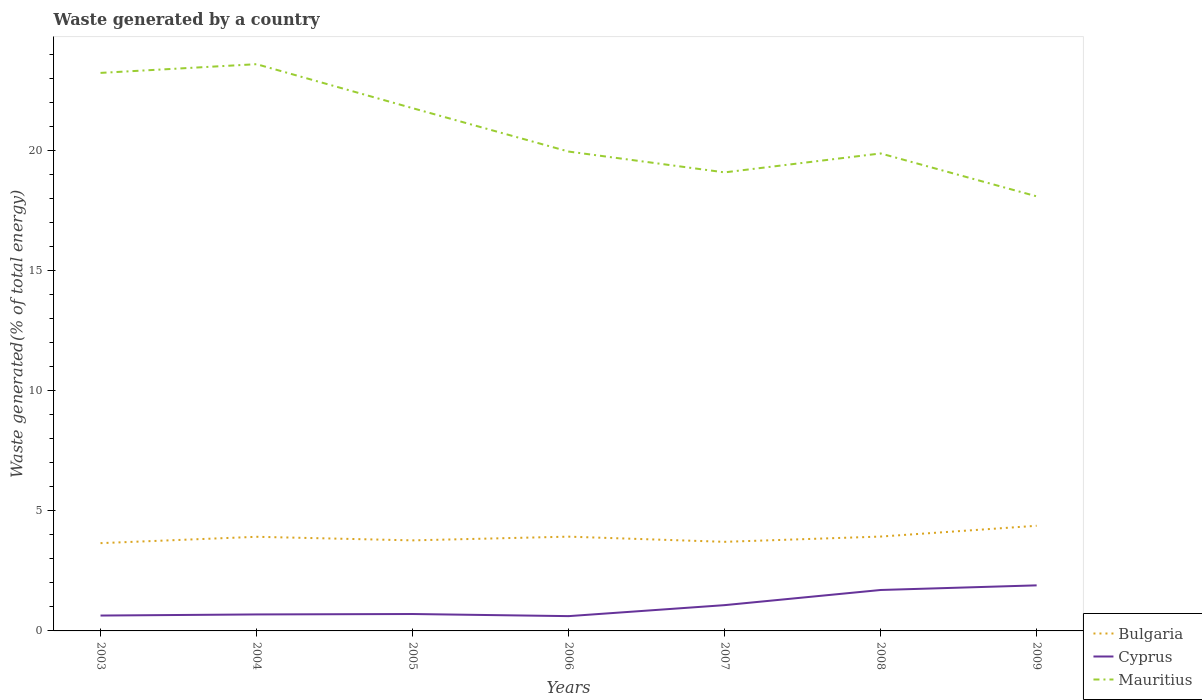Does the line corresponding to Mauritius intersect with the line corresponding to Cyprus?
Your response must be concise. No. Across all years, what is the maximum total waste generated in Cyprus?
Give a very brief answer. 0.62. What is the total total waste generated in Cyprus in the graph?
Provide a succinct answer. -0.63. What is the difference between the highest and the second highest total waste generated in Cyprus?
Offer a very short reply. 1.28. What is the difference between the highest and the lowest total waste generated in Cyprus?
Offer a very short reply. 3. How many years are there in the graph?
Provide a short and direct response. 7. Does the graph contain any zero values?
Your answer should be very brief. No. Does the graph contain grids?
Your answer should be very brief. No. Where does the legend appear in the graph?
Provide a succinct answer. Bottom right. How many legend labels are there?
Your response must be concise. 3. What is the title of the graph?
Your answer should be very brief. Waste generated by a country. Does "Cote d'Ivoire" appear as one of the legend labels in the graph?
Make the answer very short. No. What is the label or title of the X-axis?
Your response must be concise. Years. What is the label or title of the Y-axis?
Provide a succinct answer. Waste generated(% of total energy). What is the Waste generated(% of total energy) of Bulgaria in 2003?
Your answer should be compact. 3.66. What is the Waste generated(% of total energy) in Cyprus in 2003?
Your response must be concise. 0.64. What is the Waste generated(% of total energy) of Mauritius in 2003?
Offer a very short reply. 23.24. What is the Waste generated(% of total energy) of Bulgaria in 2004?
Give a very brief answer. 3.92. What is the Waste generated(% of total energy) in Cyprus in 2004?
Give a very brief answer. 0.69. What is the Waste generated(% of total energy) in Mauritius in 2004?
Give a very brief answer. 23.6. What is the Waste generated(% of total energy) of Bulgaria in 2005?
Offer a terse response. 3.77. What is the Waste generated(% of total energy) of Cyprus in 2005?
Give a very brief answer. 0.7. What is the Waste generated(% of total energy) in Mauritius in 2005?
Your answer should be very brief. 21.77. What is the Waste generated(% of total energy) in Bulgaria in 2006?
Your answer should be compact. 3.93. What is the Waste generated(% of total energy) in Cyprus in 2006?
Make the answer very short. 0.62. What is the Waste generated(% of total energy) of Mauritius in 2006?
Provide a succinct answer. 19.96. What is the Waste generated(% of total energy) of Bulgaria in 2007?
Keep it short and to the point. 3.71. What is the Waste generated(% of total energy) in Cyprus in 2007?
Give a very brief answer. 1.07. What is the Waste generated(% of total energy) of Mauritius in 2007?
Keep it short and to the point. 19.1. What is the Waste generated(% of total energy) of Bulgaria in 2008?
Your answer should be compact. 3.93. What is the Waste generated(% of total energy) in Cyprus in 2008?
Offer a very short reply. 1.7. What is the Waste generated(% of total energy) in Mauritius in 2008?
Offer a terse response. 19.88. What is the Waste generated(% of total energy) of Bulgaria in 2009?
Keep it short and to the point. 4.38. What is the Waste generated(% of total energy) in Cyprus in 2009?
Your response must be concise. 1.9. What is the Waste generated(% of total energy) of Mauritius in 2009?
Make the answer very short. 18.1. Across all years, what is the maximum Waste generated(% of total energy) in Bulgaria?
Your answer should be compact. 4.38. Across all years, what is the maximum Waste generated(% of total energy) of Cyprus?
Offer a terse response. 1.9. Across all years, what is the maximum Waste generated(% of total energy) of Mauritius?
Provide a short and direct response. 23.6. Across all years, what is the minimum Waste generated(% of total energy) in Bulgaria?
Your answer should be very brief. 3.66. Across all years, what is the minimum Waste generated(% of total energy) in Cyprus?
Ensure brevity in your answer.  0.62. Across all years, what is the minimum Waste generated(% of total energy) in Mauritius?
Your response must be concise. 18.1. What is the total Waste generated(% of total energy) in Bulgaria in the graph?
Keep it short and to the point. 27.29. What is the total Waste generated(% of total energy) in Cyprus in the graph?
Offer a terse response. 7.32. What is the total Waste generated(% of total energy) of Mauritius in the graph?
Offer a very short reply. 145.65. What is the difference between the Waste generated(% of total energy) in Bulgaria in 2003 and that in 2004?
Your response must be concise. -0.26. What is the difference between the Waste generated(% of total energy) of Cyprus in 2003 and that in 2004?
Your answer should be very brief. -0.05. What is the difference between the Waste generated(% of total energy) of Mauritius in 2003 and that in 2004?
Give a very brief answer. -0.36. What is the difference between the Waste generated(% of total energy) of Bulgaria in 2003 and that in 2005?
Give a very brief answer. -0.12. What is the difference between the Waste generated(% of total energy) of Cyprus in 2003 and that in 2005?
Offer a very short reply. -0.06. What is the difference between the Waste generated(% of total energy) in Mauritius in 2003 and that in 2005?
Ensure brevity in your answer.  1.47. What is the difference between the Waste generated(% of total energy) of Bulgaria in 2003 and that in 2006?
Make the answer very short. -0.27. What is the difference between the Waste generated(% of total energy) in Cyprus in 2003 and that in 2006?
Give a very brief answer. 0.02. What is the difference between the Waste generated(% of total energy) of Mauritius in 2003 and that in 2006?
Offer a terse response. 3.28. What is the difference between the Waste generated(% of total energy) of Bulgaria in 2003 and that in 2007?
Your answer should be compact. -0.06. What is the difference between the Waste generated(% of total energy) of Cyprus in 2003 and that in 2007?
Offer a very short reply. -0.43. What is the difference between the Waste generated(% of total energy) of Mauritius in 2003 and that in 2007?
Give a very brief answer. 4.14. What is the difference between the Waste generated(% of total energy) in Bulgaria in 2003 and that in 2008?
Keep it short and to the point. -0.27. What is the difference between the Waste generated(% of total energy) in Cyprus in 2003 and that in 2008?
Give a very brief answer. -1.06. What is the difference between the Waste generated(% of total energy) in Mauritius in 2003 and that in 2008?
Make the answer very short. 3.35. What is the difference between the Waste generated(% of total energy) in Bulgaria in 2003 and that in 2009?
Keep it short and to the point. -0.72. What is the difference between the Waste generated(% of total energy) in Cyprus in 2003 and that in 2009?
Your answer should be very brief. -1.26. What is the difference between the Waste generated(% of total energy) of Mauritius in 2003 and that in 2009?
Make the answer very short. 5.14. What is the difference between the Waste generated(% of total energy) of Bulgaria in 2004 and that in 2005?
Provide a succinct answer. 0.15. What is the difference between the Waste generated(% of total energy) of Cyprus in 2004 and that in 2005?
Your answer should be compact. -0.02. What is the difference between the Waste generated(% of total energy) in Mauritius in 2004 and that in 2005?
Your answer should be very brief. 1.83. What is the difference between the Waste generated(% of total energy) of Bulgaria in 2004 and that in 2006?
Offer a very short reply. -0.01. What is the difference between the Waste generated(% of total energy) in Cyprus in 2004 and that in 2006?
Provide a succinct answer. 0.07. What is the difference between the Waste generated(% of total energy) of Mauritius in 2004 and that in 2006?
Ensure brevity in your answer.  3.64. What is the difference between the Waste generated(% of total energy) in Bulgaria in 2004 and that in 2007?
Your response must be concise. 0.21. What is the difference between the Waste generated(% of total energy) in Cyprus in 2004 and that in 2007?
Your response must be concise. -0.39. What is the difference between the Waste generated(% of total energy) of Mauritius in 2004 and that in 2007?
Provide a short and direct response. 4.51. What is the difference between the Waste generated(% of total energy) of Bulgaria in 2004 and that in 2008?
Offer a very short reply. -0.01. What is the difference between the Waste generated(% of total energy) of Cyprus in 2004 and that in 2008?
Offer a terse response. -1.02. What is the difference between the Waste generated(% of total energy) in Mauritius in 2004 and that in 2008?
Your answer should be compact. 3.72. What is the difference between the Waste generated(% of total energy) of Bulgaria in 2004 and that in 2009?
Ensure brevity in your answer.  -0.46. What is the difference between the Waste generated(% of total energy) in Cyprus in 2004 and that in 2009?
Ensure brevity in your answer.  -1.21. What is the difference between the Waste generated(% of total energy) in Mauritius in 2004 and that in 2009?
Make the answer very short. 5.5. What is the difference between the Waste generated(% of total energy) of Bulgaria in 2005 and that in 2006?
Provide a succinct answer. -0.15. What is the difference between the Waste generated(% of total energy) in Cyprus in 2005 and that in 2006?
Offer a very short reply. 0.09. What is the difference between the Waste generated(% of total energy) in Mauritius in 2005 and that in 2006?
Your response must be concise. 1.81. What is the difference between the Waste generated(% of total energy) of Bulgaria in 2005 and that in 2007?
Give a very brief answer. 0.06. What is the difference between the Waste generated(% of total energy) in Cyprus in 2005 and that in 2007?
Your response must be concise. -0.37. What is the difference between the Waste generated(% of total energy) in Mauritius in 2005 and that in 2007?
Your answer should be very brief. 2.67. What is the difference between the Waste generated(% of total energy) in Bulgaria in 2005 and that in 2008?
Give a very brief answer. -0.16. What is the difference between the Waste generated(% of total energy) in Cyprus in 2005 and that in 2008?
Ensure brevity in your answer.  -1. What is the difference between the Waste generated(% of total energy) of Mauritius in 2005 and that in 2008?
Keep it short and to the point. 1.89. What is the difference between the Waste generated(% of total energy) of Bulgaria in 2005 and that in 2009?
Ensure brevity in your answer.  -0.61. What is the difference between the Waste generated(% of total energy) in Cyprus in 2005 and that in 2009?
Give a very brief answer. -1.19. What is the difference between the Waste generated(% of total energy) in Mauritius in 2005 and that in 2009?
Ensure brevity in your answer.  3.67. What is the difference between the Waste generated(% of total energy) of Bulgaria in 2006 and that in 2007?
Your response must be concise. 0.22. What is the difference between the Waste generated(% of total energy) of Cyprus in 2006 and that in 2007?
Keep it short and to the point. -0.46. What is the difference between the Waste generated(% of total energy) of Mauritius in 2006 and that in 2007?
Your answer should be very brief. 0.87. What is the difference between the Waste generated(% of total energy) of Bulgaria in 2006 and that in 2008?
Provide a succinct answer. -0. What is the difference between the Waste generated(% of total energy) of Cyprus in 2006 and that in 2008?
Make the answer very short. -1.09. What is the difference between the Waste generated(% of total energy) of Mauritius in 2006 and that in 2008?
Offer a very short reply. 0.08. What is the difference between the Waste generated(% of total energy) in Bulgaria in 2006 and that in 2009?
Make the answer very short. -0.45. What is the difference between the Waste generated(% of total energy) of Cyprus in 2006 and that in 2009?
Your response must be concise. -1.28. What is the difference between the Waste generated(% of total energy) of Mauritius in 2006 and that in 2009?
Offer a terse response. 1.87. What is the difference between the Waste generated(% of total energy) in Bulgaria in 2007 and that in 2008?
Keep it short and to the point. -0.22. What is the difference between the Waste generated(% of total energy) of Cyprus in 2007 and that in 2008?
Offer a very short reply. -0.63. What is the difference between the Waste generated(% of total energy) in Mauritius in 2007 and that in 2008?
Ensure brevity in your answer.  -0.79. What is the difference between the Waste generated(% of total energy) in Bulgaria in 2007 and that in 2009?
Give a very brief answer. -0.67. What is the difference between the Waste generated(% of total energy) of Cyprus in 2007 and that in 2009?
Give a very brief answer. -0.82. What is the difference between the Waste generated(% of total energy) of Bulgaria in 2008 and that in 2009?
Your answer should be compact. -0.45. What is the difference between the Waste generated(% of total energy) in Cyprus in 2008 and that in 2009?
Offer a terse response. -0.19. What is the difference between the Waste generated(% of total energy) in Mauritius in 2008 and that in 2009?
Your answer should be compact. 1.79. What is the difference between the Waste generated(% of total energy) of Bulgaria in 2003 and the Waste generated(% of total energy) of Cyprus in 2004?
Offer a very short reply. 2.97. What is the difference between the Waste generated(% of total energy) of Bulgaria in 2003 and the Waste generated(% of total energy) of Mauritius in 2004?
Make the answer very short. -19.95. What is the difference between the Waste generated(% of total energy) in Cyprus in 2003 and the Waste generated(% of total energy) in Mauritius in 2004?
Your answer should be very brief. -22.96. What is the difference between the Waste generated(% of total energy) of Bulgaria in 2003 and the Waste generated(% of total energy) of Cyprus in 2005?
Make the answer very short. 2.95. What is the difference between the Waste generated(% of total energy) in Bulgaria in 2003 and the Waste generated(% of total energy) in Mauritius in 2005?
Provide a short and direct response. -18.11. What is the difference between the Waste generated(% of total energy) in Cyprus in 2003 and the Waste generated(% of total energy) in Mauritius in 2005?
Offer a very short reply. -21.13. What is the difference between the Waste generated(% of total energy) in Bulgaria in 2003 and the Waste generated(% of total energy) in Cyprus in 2006?
Offer a very short reply. 3.04. What is the difference between the Waste generated(% of total energy) of Bulgaria in 2003 and the Waste generated(% of total energy) of Mauritius in 2006?
Offer a terse response. -16.31. What is the difference between the Waste generated(% of total energy) in Cyprus in 2003 and the Waste generated(% of total energy) in Mauritius in 2006?
Ensure brevity in your answer.  -19.32. What is the difference between the Waste generated(% of total energy) of Bulgaria in 2003 and the Waste generated(% of total energy) of Cyprus in 2007?
Provide a succinct answer. 2.58. What is the difference between the Waste generated(% of total energy) of Bulgaria in 2003 and the Waste generated(% of total energy) of Mauritius in 2007?
Keep it short and to the point. -15.44. What is the difference between the Waste generated(% of total energy) of Cyprus in 2003 and the Waste generated(% of total energy) of Mauritius in 2007?
Offer a terse response. -18.46. What is the difference between the Waste generated(% of total energy) of Bulgaria in 2003 and the Waste generated(% of total energy) of Cyprus in 2008?
Your answer should be very brief. 1.95. What is the difference between the Waste generated(% of total energy) of Bulgaria in 2003 and the Waste generated(% of total energy) of Mauritius in 2008?
Ensure brevity in your answer.  -16.23. What is the difference between the Waste generated(% of total energy) of Cyprus in 2003 and the Waste generated(% of total energy) of Mauritius in 2008?
Your answer should be very brief. -19.24. What is the difference between the Waste generated(% of total energy) in Bulgaria in 2003 and the Waste generated(% of total energy) in Cyprus in 2009?
Provide a short and direct response. 1.76. What is the difference between the Waste generated(% of total energy) in Bulgaria in 2003 and the Waste generated(% of total energy) in Mauritius in 2009?
Make the answer very short. -14.44. What is the difference between the Waste generated(% of total energy) in Cyprus in 2003 and the Waste generated(% of total energy) in Mauritius in 2009?
Your answer should be very brief. -17.46. What is the difference between the Waste generated(% of total energy) in Bulgaria in 2004 and the Waste generated(% of total energy) in Cyprus in 2005?
Keep it short and to the point. 3.22. What is the difference between the Waste generated(% of total energy) in Bulgaria in 2004 and the Waste generated(% of total energy) in Mauritius in 2005?
Your answer should be compact. -17.85. What is the difference between the Waste generated(% of total energy) in Cyprus in 2004 and the Waste generated(% of total energy) in Mauritius in 2005?
Your answer should be very brief. -21.08. What is the difference between the Waste generated(% of total energy) in Bulgaria in 2004 and the Waste generated(% of total energy) in Cyprus in 2006?
Your response must be concise. 3.3. What is the difference between the Waste generated(% of total energy) in Bulgaria in 2004 and the Waste generated(% of total energy) in Mauritius in 2006?
Your answer should be very brief. -16.04. What is the difference between the Waste generated(% of total energy) in Cyprus in 2004 and the Waste generated(% of total energy) in Mauritius in 2006?
Your answer should be very brief. -19.28. What is the difference between the Waste generated(% of total energy) of Bulgaria in 2004 and the Waste generated(% of total energy) of Cyprus in 2007?
Offer a very short reply. 2.85. What is the difference between the Waste generated(% of total energy) in Bulgaria in 2004 and the Waste generated(% of total energy) in Mauritius in 2007?
Your response must be concise. -15.18. What is the difference between the Waste generated(% of total energy) in Cyprus in 2004 and the Waste generated(% of total energy) in Mauritius in 2007?
Your response must be concise. -18.41. What is the difference between the Waste generated(% of total energy) of Bulgaria in 2004 and the Waste generated(% of total energy) of Cyprus in 2008?
Your answer should be very brief. 2.22. What is the difference between the Waste generated(% of total energy) in Bulgaria in 2004 and the Waste generated(% of total energy) in Mauritius in 2008?
Offer a very short reply. -15.96. What is the difference between the Waste generated(% of total energy) in Cyprus in 2004 and the Waste generated(% of total energy) in Mauritius in 2008?
Make the answer very short. -19.2. What is the difference between the Waste generated(% of total energy) of Bulgaria in 2004 and the Waste generated(% of total energy) of Cyprus in 2009?
Your response must be concise. 2.02. What is the difference between the Waste generated(% of total energy) of Bulgaria in 2004 and the Waste generated(% of total energy) of Mauritius in 2009?
Provide a succinct answer. -14.18. What is the difference between the Waste generated(% of total energy) in Cyprus in 2004 and the Waste generated(% of total energy) in Mauritius in 2009?
Offer a terse response. -17.41. What is the difference between the Waste generated(% of total energy) of Bulgaria in 2005 and the Waste generated(% of total energy) of Cyprus in 2006?
Offer a terse response. 3.16. What is the difference between the Waste generated(% of total energy) of Bulgaria in 2005 and the Waste generated(% of total energy) of Mauritius in 2006?
Make the answer very short. -16.19. What is the difference between the Waste generated(% of total energy) in Cyprus in 2005 and the Waste generated(% of total energy) in Mauritius in 2006?
Offer a terse response. -19.26. What is the difference between the Waste generated(% of total energy) of Bulgaria in 2005 and the Waste generated(% of total energy) of Cyprus in 2007?
Offer a terse response. 2.7. What is the difference between the Waste generated(% of total energy) of Bulgaria in 2005 and the Waste generated(% of total energy) of Mauritius in 2007?
Offer a terse response. -15.32. What is the difference between the Waste generated(% of total energy) of Cyprus in 2005 and the Waste generated(% of total energy) of Mauritius in 2007?
Keep it short and to the point. -18.39. What is the difference between the Waste generated(% of total energy) of Bulgaria in 2005 and the Waste generated(% of total energy) of Cyprus in 2008?
Offer a very short reply. 2.07. What is the difference between the Waste generated(% of total energy) of Bulgaria in 2005 and the Waste generated(% of total energy) of Mauritius in 2008?
Your answer should be very brief. -16.11. What is the difference between the Waste generated(% of total energy) in Cyprus in 2005 and the Waste generated(% of total energy) in Mauritius in 2008?
Your answer should be very brief. -19.18. What is the difference between the Waste generated(% of total energy) of Bulgaria in 2005 and the Waste generated(% of total energy) of Cyprus in 2009?
Your response must be concise. 1.87. What is the difference between the Waste generated(% of total energy) in Bulgaria in 2005 and the Waste generated(% of total energy) in Mauritius in 2009?
Keep it short and to the point. -14.33. What is the difference between the Waste generated(% of total energy) of Cyprus in 2005 and the Waste generated(% of total energy) of Mauritius in 2009?
Your answer should be compact. -17.39. What is the difference between the Waste generated(% of total energy) of Bulgaria in 2006 and the Waste generated(% of total energy) of Cyprus in 2007?
Provide a short and direct response. 2.85. What is the difference between the Waste generated(% of total energy) of Bulgaria in 2006 and the Waste generated(% of total energy) of Mauritius in 2007?
Offer a terse response. -15.17. What is the difference between the Waste generated(% of total energy) of Cyprus in 2006 and the Waste generated(% of total energy) of Mauritius in 2007?
Make the answer very short. -18.48. What is the difference between the Waste generated(% of total energy) in Bulgaria in 2006 and the Waste generated(% of total energy) in Cyprus in 2008?
Offer a very short reply. 2.22. What is the difference between the Waste generated(% of total energy) of Bulgaria in 2006 and the Waste generated(% of total energy) of Mauritius in 2008?
Make the answer very short. -15.96. What is the difference between the Waste generated(% of total energy) in Cyprus in 2006 and the Waste generated(% of total energy) in Mauritius in 2008?
Ensure brevity in your answer.  -19.27. What is the difference between the Waste generated(% of total energy) in Bulgaria in 2006 and the Waste generated(% of total energy) in Cyprus in 2009?
Your answer should be compact. 2.03. What is the difference between the Waste generated(% of total energy) of Bulgaria in 2006 and the Waste generated(% of total energy) of Mauritius in 2009?
Keep it short and to the point. -14.17. What is the difference between the Waste generated(% of total energy) of Cyprus in 2006 and the Waste generated(% of total energy) of Mauritius in 2009?
Ensure brevity in your answer.  -17.48. What is the difference between the Waste generated(% of total energy) in Bulgaria in 2007 and the Waste generated(% of total energy) in Cyprus in 2008?
Your answer should be compact. 2.01. What is the difference between the Waste generated(% of total energy) in Bulgaria in 2007 and the Waste generated(% of total energy) in Mauritius in 2008?
Give a very brief answer. -16.17. What is the difference between the Waste generated(% of total energy) in Cyprus in 2007 and the Waste generated(% of total energy) in Mauritius in 2008?
Provide a succinct answer. -18.81. What is the difference between the Waste generated(% of total energy) in Bulgaria in 2007 and the Waste generated(% of total energy) in Cyprus in 2009?
Offer a very short reply. 1.81. What is the difference between the Waste generated(% of total energy) in Bulgaria in 2007 and the Waste generated(% of total energy) in Mauritius in 2009?
Ensure brevity in your answer.  -14.39. What is the difference between the Waste generated(% of total energy) in Cyprus in 2007 and the Waste generated(% of total energy) in Mauritius in 2009?
Provide a short and direct response. -17.02. What is the difference between the Waste generated(% of total energy) in Bulgaria in 2008 and the Waste generated(% of total energy) in Cyprus in 2009?
Provide a short and direct response. 2.03. What is the difference between the Waste generated(% of total energy) in Bulgaria in 2008 and the Waste generated(% of total energy) in Mauritius in 2009?
Ensure brevity in your answer.  -14.17. What is the difference between the Waste generated(% of total energy) in Cyprus in 2008 and the Waste generated(% of total energy) in Mauritius in 2009?
Your answer should be compact. -16.39. What is the average Waste generated(% of total energy) of Bulgaria per year?
Provide a short and direct response. 3.9. What is the average Waste generated(% of total energy) in Cyprus per year?
Your answer should be compact. 1.05. What is the average Waste generated(% of total energy) of Mauritius per year?
Your response must be concise. 20.81. In the year 2003, what is the difference between the Waste generated(% of total energy) of Bulgaria and Waste generated(% of total energy) of Cyprus?
Give a very brief answer. 3.02. In the year 2003, what is the difference between the Waste generated(% of total energy) in Bulgaria and Waste generated(% of total energy) in Mauritius?
Ensure brevity in your answer.  -19.58. In the year 2003, what is the difference between the Waste generated(% of total energy) in Cyprus and Waste generated(% of total energy) in Mauritius?
Make the answer very short. -22.6. In the year 2004, what is the difference between the Waste generated(% of total energy) of Bulgaria and Waste generated(% of total energy) of Cyprus?
Give a very brief answer. 3.23. In the year 2004, what is the difference between the Waste generated(% of total energy) of Bulgaria and Waste generated(% of total energy) of Mauritius?
Your response must be concise. -19.68. In the year 2004, what is the difference between the Waste generated(% of total energy) of Cyprus and Waste generated(% of total energy) of Mauritius?
Offer a very short reply. -22.92. In the year 2005, what is the difference between the Waste generated(% of total energy) in Bulgaria and Waste generated(% of total energy) in Cyprus?
Offer a very short reply. 3.07. In the year 2005, what is the difference between the Waste generated(% of total energy) in Bulgaria and Waste generated(% of total energy) in Mauritius?
Keep it short and to the point. -18. In the year 2005, what is the difference between the Waste generated(% of total energy) in Cyprus and Waste generated(% of total energy) in Mauritius?
Your answer should be very brief. -21.07. In the year 2006, what is the difference between the Waste generated(% of total energy) in Bulgaria and Waste generated(% of total energy) in Cyprus?
Ensure brevity in your answer.  3.31. In the year 2006, what is the difference between the Waste generated(% of total energy) of Bulgaria and Waste generated(% of total energy) of Mauritius?
Ensure brevity in your answer.  -16.04. In the year 2006, what is the difference between the Waste generated(% of total energy) in Cyprus and Waste generated(% of total energy) in Mauritius?
Give a very brief answer. -19.35. In the year 2007, what is the difference between the Waste generated(% of total energy) of Bulgaria and Waste generated(% of total energy) of Cyprus?
Your answer should be very brief. 2.64. In the year 2007, what is the difference between the Waste generated(% of total energy) in Bulgaria and Waste generated(% of total energy) in Mauritius?
Your answer should be compact. -15.39. In the year 2007, what is the difference between the Waste generated(% of total energy) in Cyprus and Waste generated(% of total energy) in Mauritius?
Give a very brief answer. -18.02. In the year 2008, what is the difference between the Waste generated(% of total energy) in Bulgaria and Waste generated(% of total energy) in Cyprus?
Offer a terse response. 2.23. In the year 2008, what is the difference between the Waste generated(% of total energy) of Bulgaria and Waste generated(% of total energy) of Mauritius?
Your answer should be very brief. -15.95. In the year 2008, what is the difference between the Waste generated(% of total energy) in Cyprus and Waste generated(% of total energy) in Mauritius?
Offer a terse response. -18.18. In the year 2009, what is the difference between the Waste generated(% of total energy) of Bulgaria and Waste generated(% of total energy) of Cyprus?
Offer a terse response. 2.48. In the year 2009, what is the difference between the Waste generated(% of total energy) of Bulgaria and Waste generated(% of total energy) of Mauritius?
Keep it short and to the point. -13.72. In the year 2009, what is the difference between the Waste generated(% of total energy) in Cyprus and Waste generated(% of total energy) in Mauritius?
Offer a terse response. -16.2. What is the ratio of the Waste generated(% of total energy) of Bulgaria in 2003 to that in 2004?
Ensure brevity in your answer.  0.93. What is the ratio of the Waste generated(% of total energy) in Cyprus in 2003 to that in 2004?
Offer a terse response. 0.93. What is the ratio of the Waste generated(% of total energy) in Mauritius in 2003 to that in 2004?
Make the answer very short. 0.98. What is the ratio of the Waste generated(% of total energy) in Bulgaria in 2003 to that in 2005?
Provide a short and direct response. 0.97. What is the ratio of the Waste generated(% of total energy) of Cyprus in 2003 to that in 2005?
Give a very brief answer. 0.91. What is the ratio of the Waste generated(% of total energy) in Mauritius in 2003 to that in 2005?
Your answer should be very brief. 1.07. What is the ratio of the Waste generated(% of total energy) of Bulgaria in 2003 to that in 2006?
Your answer should be compact. 0.93. What is the ratio of the Waste generated(% of total energy) in Cyprus in 2003 to that in 2006?
Provide a succinct answer. 1.04. What is the ratio of the Waste generated(% of total energy) of Mauritius in 2003 to that in 2006?
Offer a very short reply. 1.16. What is the ratio of the Waste generated(% of total energy) in Bulgaria in 2003 to that in 2007?
Your answer should be compact. 0.99. What is the ratio of the Waste generated(% of total energy) in Cyprus in 2003 to that in 2007?
Your response must be concise. 0.6. What is the ratio of the Waste generated(% of total energy) in Mauritius in 2003 to that in 2007?
Keep it short and to the point. 1.22. What is the ratio of the Waste generated(% of total energy) of Bulgaria in 2003 to that in 2008?
Offer a very short reply. 0.93. What is the ratio of the Waste generated(% of total energy) in Cyprus in 2003 to that in 2008?
Give a very brief answer. 0.38. What is the ratio of the Waste generated(% of total energy) in Mauritius in 2003 to that in 2008?
Your answer should be very brief. 1.17. What is the ratio of the Waste generated(% of total energy) of Bulgaria in 2003 to that in 2009?
Offer a very short reply. 0.83. What is the ratio of the Waste generated(% of total energy) of Cyprus in 2003 to that in 2009?
Your response must be concise. 0.34. What is the ratio of the Waste generated(% of total energy) of Mauritius in 2003 to that in 2009?
Make the answer very short. 1.28. What is the ratio of the Waste generated(% of total energy) in Bulgaria in 2004 to that in 2005?
Your response must be concise. 1.04. What is the ratio of the Waste generated(% of total energy) of Cyprus in 2004 to that in 2005?
Provide a succinct answer. 0.97. What is the ratio of the Waste generated(% of total energy) of Mauritius in 2004 to that in 2005?
Your response must be concise. 1.08. What is the ratio of the Waste generated(% of total energy) in Bulgaria in 2004 to that in 2006?
Provide a short and direct response. 1. What is the ratio of the Waste generated(% of total energy) of Cyprus in 2004 to that in 2006?
Provide a short and direct response. 1.11. What is the ratio of the Waste generated(% of total energy) in Mauritius in 2004 to that in 2006?
Offer a terse response. 1.18. What is the ratio of the Waste generated(% of total energy) of Bulgaria in 2004 to that in 2007?
Ensure brevity in your answer.  1.06. What is the ratio of the Waste generated(% of total energy) in Cyprus in 2004 to that in 2007?
Offer a terse response. 0.64. What is the ratio of the Waste generated(% of total energy) in Mauritius in 2004 to that in 2007?
Your response must be concise. 1.24. What is the ratio of the Waste generated(% of total energy) of Cyprus in 2004 to that in 2008?
Your response must be concise. 0.4. What is the ratio of the Waste generated(% of total energy) in Mauritius in 2004 to that in 2008?
Make the answer very short. 1.19. What is the ratio of the Waste generated(% of total energy) of Bulgaria in 2004 to that in 2009?
Your answer should be compact. 0.9. What is the ratio of the Waste generated(% of total energy) in Cyprus in 2004 to that in 2009?
Provide a succinct answer. 0.36. What is the ratio of the Waste generated(% of total energy) of Mauritius in 2004 to that in 2009?
Your answer should be compact. 1.3. What is the ratio of the Waste generated(% of total energy) of Bulgaria in 2005 to that in 2006?
Ensure brevity in your answer.  0.96. What is the ratio of the Waste generated(% of total energy) of Cyprus in 2005 to that in 2006?
Your answer should be compact. 1.14. What is the ratio of the Waste generated(% of total energy) of Mauritius in 2005 to that in 2006?
Offer a very short reply. 1.09. What is the ratio of the Waste generated(% of total energy) of Bulgaria in 2005 to that in 2007?
Your answer should be very brief. 1.02. What is the ratio of the Waste generated(% of total energy) of Cyprus in 2005 to that in 2007?
Your answer should be compact. 0.66. What is the ratio of the Waste generated(% of total energy) in Mauritius in 2005 to that in 2007?
Your answer should be compact. 1.14. What is the ratio of the Waste generated(% of total energy) of Bulgaria in 2005 to that in 2008?
Your answer should be compact. 0.96. What is the ratio of the Waste generated(% of total energy) of Cyprus in 2005 to that in 2008?
Provide a short and direct response. 0.41. What is the ratio of the Waste generated(% of total energy) in Mauritius in 2005 to that in 2008?
Offer a very short reply. 1.09. What is the ratio of the Waste generated(% of total energy) of Bulgaria in 2005 to that in 2009?
Your answer should be very brief. 0.86. What is the ratio of the Waste generated(% of total energy) of Cyprus in 2005 to that in 2009?
Give a very brief answer. 0.37. What is the ratio of the Waste generated(% of total energy) in Mauritius in 2005 to that in 2009?
Give a very brief answer. 1.2. What is the ratio of the Waste generated(% of total energy) in Bulgaria in 2006 to that in 2007?
Provide a short and direct response. 1.06. What is the ratio of the Waste generated(% of total energy) of Cyprus in 2006 to that in 2007?
Provide a succinct answer. 0.57. What is the ratio of the Waste generated(% of total energy) of Mauritius in 2006 to that in 2007?
Give a very brief answer. 1.05. What is the ratio of the Waste generated(% of total energy) in Cyprus in 2006 to that in 2008?
Your answer should be very brief. 0.36. What is the ratio of the Waste generated(% of total energy) in Bulgaria in 2006 to that in 2009?
Provide a short and direct response. 0.9. What is the ratio of the Waste generated(% of total energy) in Cyprus in 2006 to that in 2009?
Make the answer very short. 0.32. What is the ratio of the Waste generated(% of total energy) in Mauritius in 2006 to that in 2009?
Keep it short and to the point. 1.1. What is the ratio of the Waste generated(% of total energy) in Bulgaria in 2007 to that in 2008?
Your answer should be very brief. 0.94. What is the ratio of the Waste generated(% of total energy) of Cyprus in 2007 to that in 2008?
Your answer should be very brief. 0.63. What is the ratio of the Waste generated(% of total energy) of Mauritius in 2007 to that in 2008?
Your answer should be very brief. 0.96. What is the ratio of the Waste generated(% of total energy) in Bulgaria in 2007 to that in 2009?
Offer a terse response. 0.85. What is the ratio of the Waste generated(% of total energy) in Cyprus in 2007 to that in 2009?
Provide a succinct answer. 0.57. What is the ratio of the Waste generated(% of total energy) of Mauritius in 2007 to that in 2009?
Make the answer very short. 1.06. What is the ratio of the Waste generated(% of total energy) of Bulgaria in 2008 to that in 2009?
Your response must be concise. 0.9. What is the ratio of the Waste generated(% of total energy) in Cyprus in 2008 to that in 2009?
Your answer should be very brief. 0.9. What is the ratio of the Waste generated(% of total energy) in Mauritius in 2008 to that in 2009?
Your answer should be compact. 1.1. What is the difference between the highest and the second highest Waste generated(% of total energy) of Bulgaria?
Provide a short and direct response. 0.45. What is the difference between the highest and the second highest Waste generated(% of total energy) of Cyprus?
Provide a succinct answer. 0.19. What is the difference between the highest and the second highest Waste generated(% of total energy) in Mauritius?
Ensure brevity in your answer.  0.36. What is the difference between the highest and the lowest Waste generated(% of total energy) in Bulgaria?
Give a very brief answer. 0.72. What is the difference between the highest and the lowest Waste generated(% of total energy) of Cyprus?
Your answer should be very brief. 1.28. What is the difference between the highest and the lowest Waste generated(% of total energy) in Mauritius?
Keep it short and to the point. 5.5. 